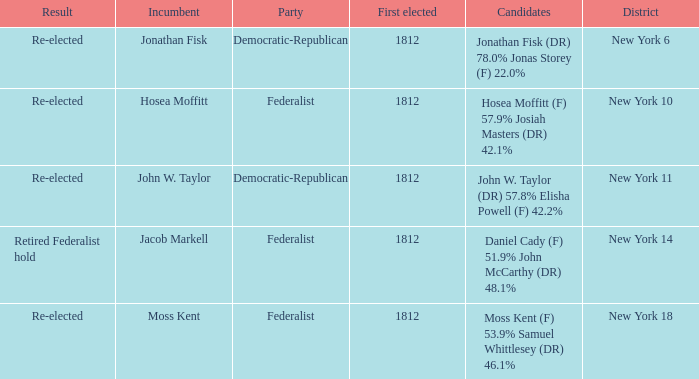Name the first elected for hosea moffitt (f) 57.9% josiah masters (dr) 42.1% 1812.0. 